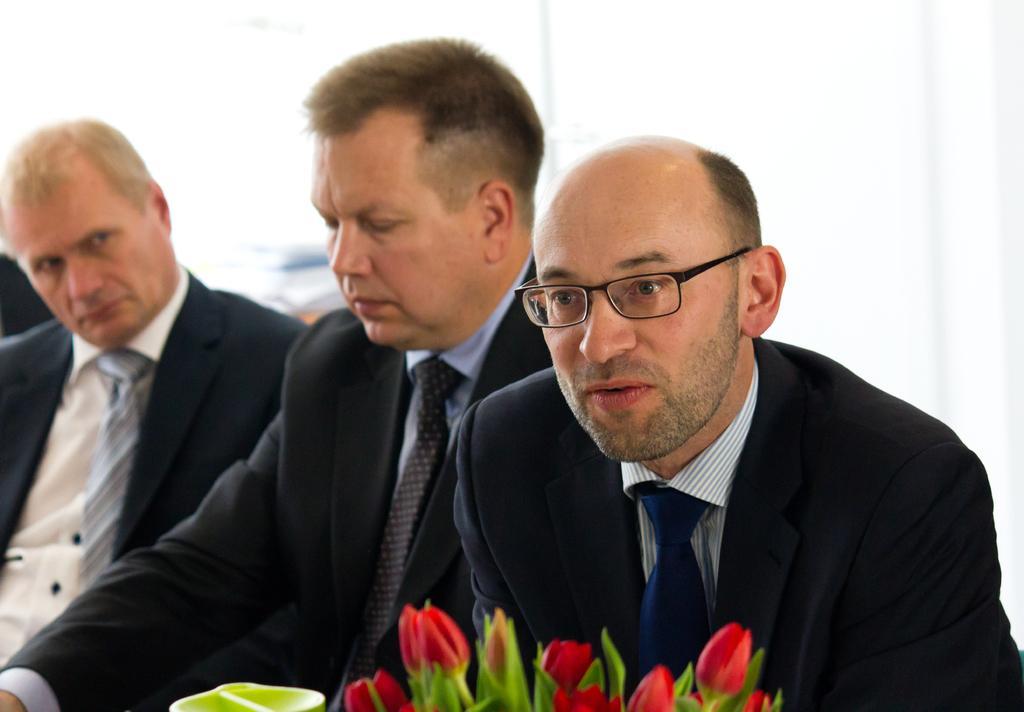Describe this image in one or two sentences. In this picture I can observe three men. All of them are wearing coats. One of them is wearing spectacles. On the bottom of the picture I can observe flowers. 